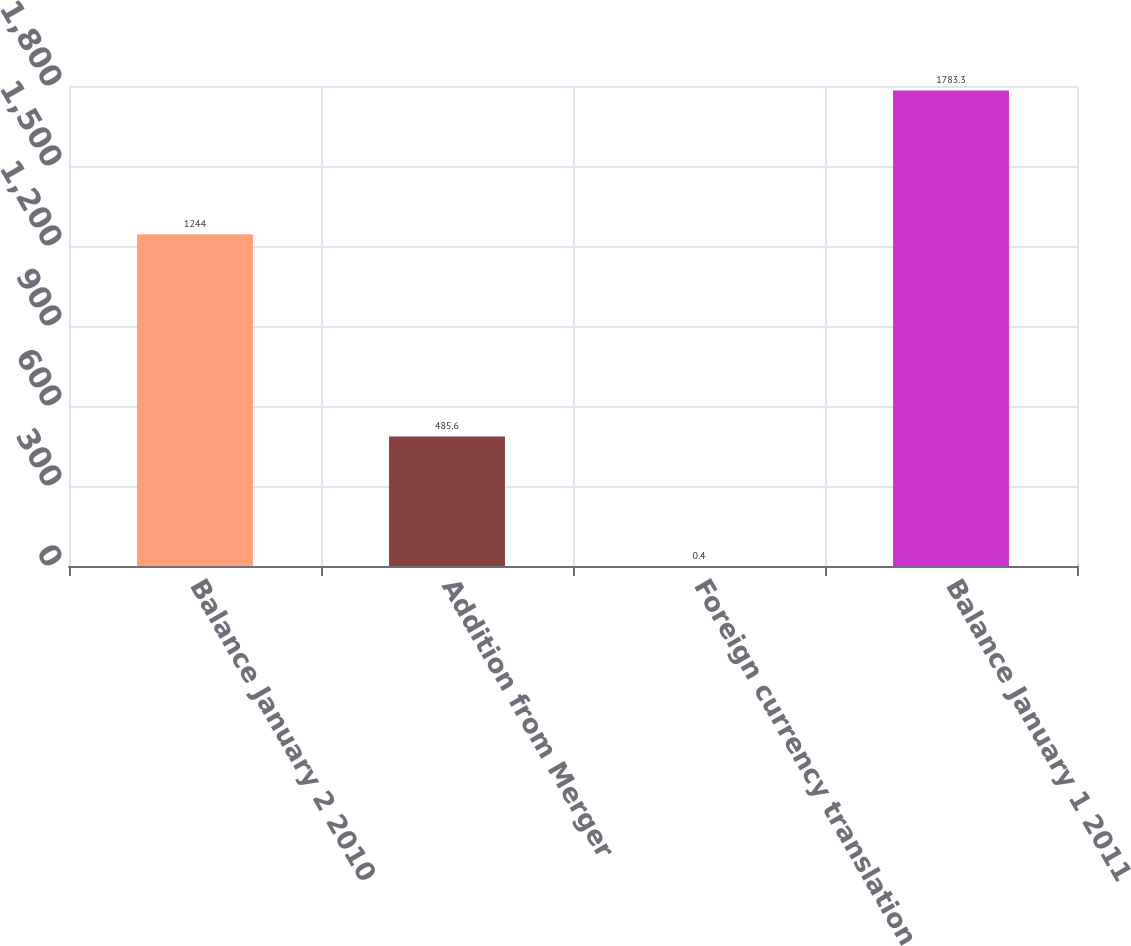Convert chart to OTSL. <chart><loc_0><loc_0><loc_500><loc_500><bar_chart><fcel>Balance January 2 2010<fcel>Addition from Merger<fcel>Foreign currency translation<fcel>Balance January 1 2011<nl><fcel>1244<fcel>485.6<fcel>0.4<fcel>1783.3<nl></chart> 